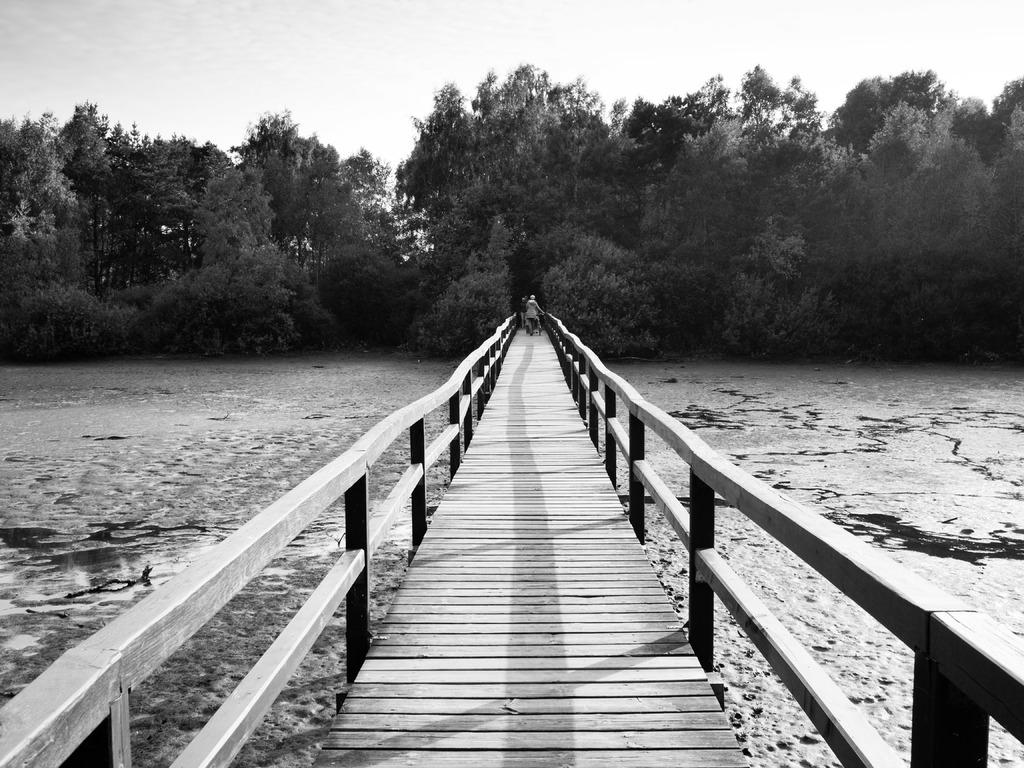What is happening in the center of the image? There are persons on the boardwalk in the center of the image. What can be seen on the left side of the image? There is water on the left side of the image. What is present on the right side of the image? There is water on the right side of the image. What type of natural scenery is visible in the background of the image? There are trees in the background of the image. What is visible in the sky in the background of the image? The sky is visible in the background of the image. Can you tell me how many chickens are walking on the boardwalk in the image? There are no chickens present in the image; it features persons on the boardwalk. What type of haircut does the tree on the right side of the image have? There are no haircuts mentioned in the image, as it features trees and water. 